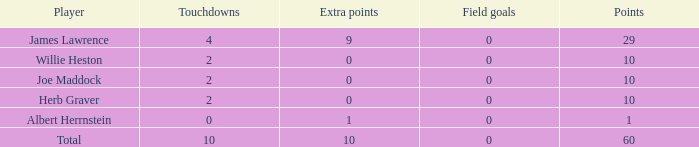What is the maximum point total for players who have fewer than 2 touchdowns and no extra points? None. 